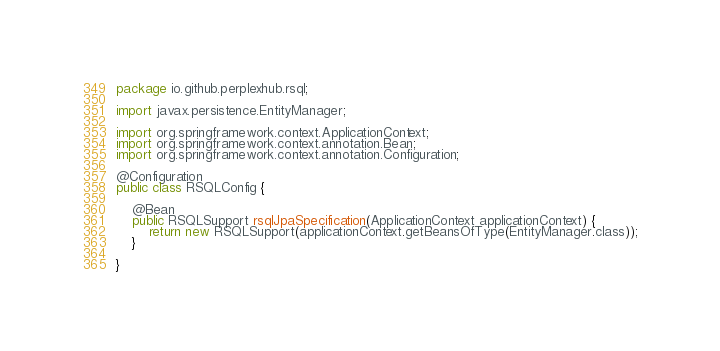Convert code to text. <code><loc_0><loc_0><loc_500><loc_500><_Java_>package io.github.perplexhub.rsql;

import javax.persistence.EntityManager;

import org.springframework.context.ApplicationContext;
import org.springframework.context.annotation.Bean;
import org.springframework.context.annotation.Configuration;

@Configuration
public class RSQLConfig {

	@Bean
	public RSQLSupport rsqlJpaSpecification(ApplicationContext applicationContext) {
		return new RSQLSupport(applicationContext.getBeansOfType(EntityManager.class));
	}

}
</code> 